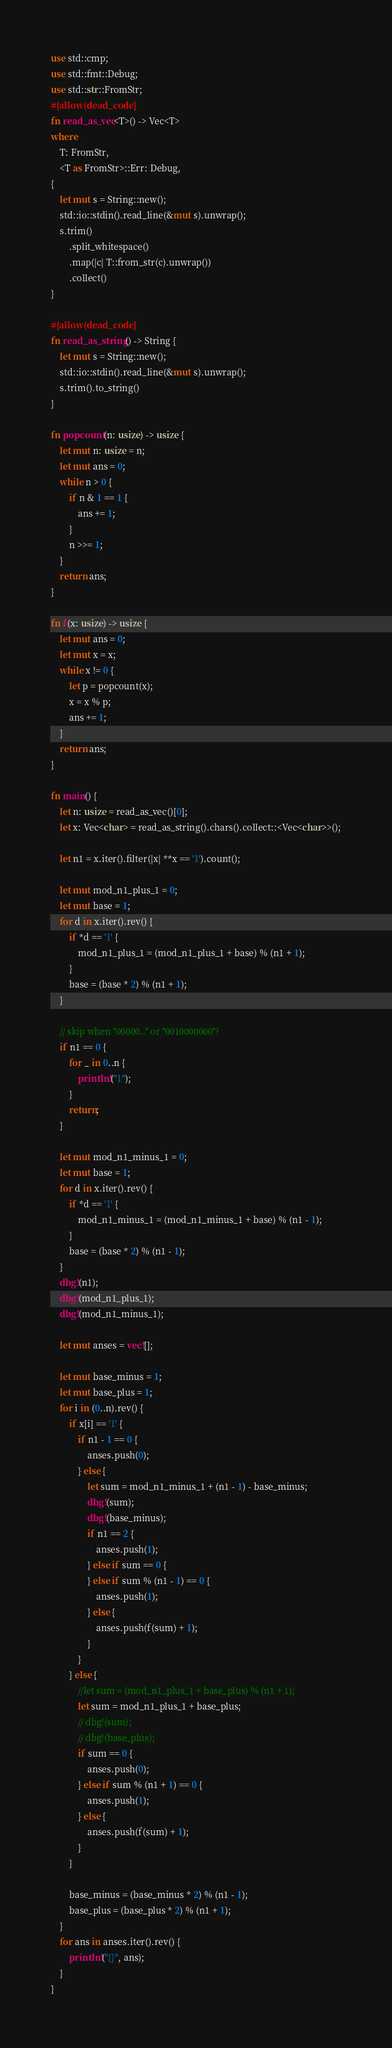Convert code to text. <code><loc_0><loc_0><loc_500><loc_500><_Rust_>use std::cmp;
use std::fmt::Debug;
use std::str::FromStr;
#[allow(dead_code)]
fn read_as_vec<T>() -> Vec<T>
where
    T: FromStr,
    <T as FromStr>::Err: Debug,
{
    let mut s = String::new();
    std::io::stdin().read_line(&mut s).unwrap();
    s.trim()
        .split_whitespace()
        .map(|c| T::from_str(c).unwrap())
        .collect()
}

#[allow(dead_code)]
fn read_as_string() -> String {
    let mut s = String::new();
    std::io::stdin().read_line(&mut s).unwrap();
    s.trim().to_string()
}

fn popcount(n: usize) -> usize {
    let mut n: usize = n;
    let mut ans = 0;
    while n > 0 {
        if n & 1 == 1 {
            ans += 1;
        }
        n >>= 1;
    }
    return ans;
}

fn f(x: usize) -> usize {
    let mut ans = 0;
    let mut x = x;
    while x != 0 {
        let p = popcount(x);
        x = x % p;
        ans += 1;
    }
    return ans;
}

fn main() {
    let n: usize = read_as_vec()[0];
    let x: Vec<char> = read_as_string().chars().collect::<Vec<char>>();

    let n1 = x.iter().filter(|x| **x == '1').count();

    let mut mod_n1_plus_1 = 0;
    let mut base = 1;
    for d in x.iter().rev() {
        if *d == '1' {
            mod_n1_plus_1 = (mod_n1_plus_1 + base) % (n1 + 1);
        }
        base = (base * 2) % (n1 + 1);
    }

    // skip when "00000.." or "0010000000"?
    if n1 == 0 {
        for _ in 0..n {
            println!("1");
        }
        return;
    }

    let mut mod_n1_minus_1 = 0;
    let mut base = 1;
    for d in x.iter().rev() {
        if *d == '1' {
            mod_n1_minus_1 = (mod_n1_minus_1 + base) % (n1 - 1);
        }
        base = (base * 2) % (n1 - 1);
    }
    dbg!(n1);
    dbg!(mod_n1_plus_1);
    dbg!(mod_n1_minus_1);

    let mut anses = vec![];

    let mut base_minus = 1;
    let mut base_plus = 1;
    for i in (0..n).rev() {
        if x[i] == '1' {
            if n1 - 1 == 0 {
                anses.push(0);
            } else {
                let sum = mod_n1_minus_1 + (n1 - 1) - base_minus;
                dbg!(sum);
                dbg!(base_minus);
                if n1 == 2 {
                    anses.push(1);
                } else if sum == 0 {
                } else if sum % (n1 - 1) == 0 {
                    anses.push(1);
                } else {
                    anses.push(f(sum) + 1);
                }
            }
        } else {
            //let sum = (mod_n1_plus_1 + base_plus) % (n1 + 1);
            let sum = mod_n1_plus_1 + base_plus;
            // dbg!(sum);
            // dbg!(base_plus);
            if sum == 0 {
                anses.push(0);
            } else if sum % (n1 + 1) == 0 {
                anses.push(1);
            } else {
                anses.push(f(sum) + 1);
            }
        }

        base_minus = (base_minus * 2) % (n1 - 1);
        base_plus = (base_plus * 2) % (n1 + 1);
    }
    for ans in anses.iter().rev() {
        println!("{}", ans);
    }
}
</code> 